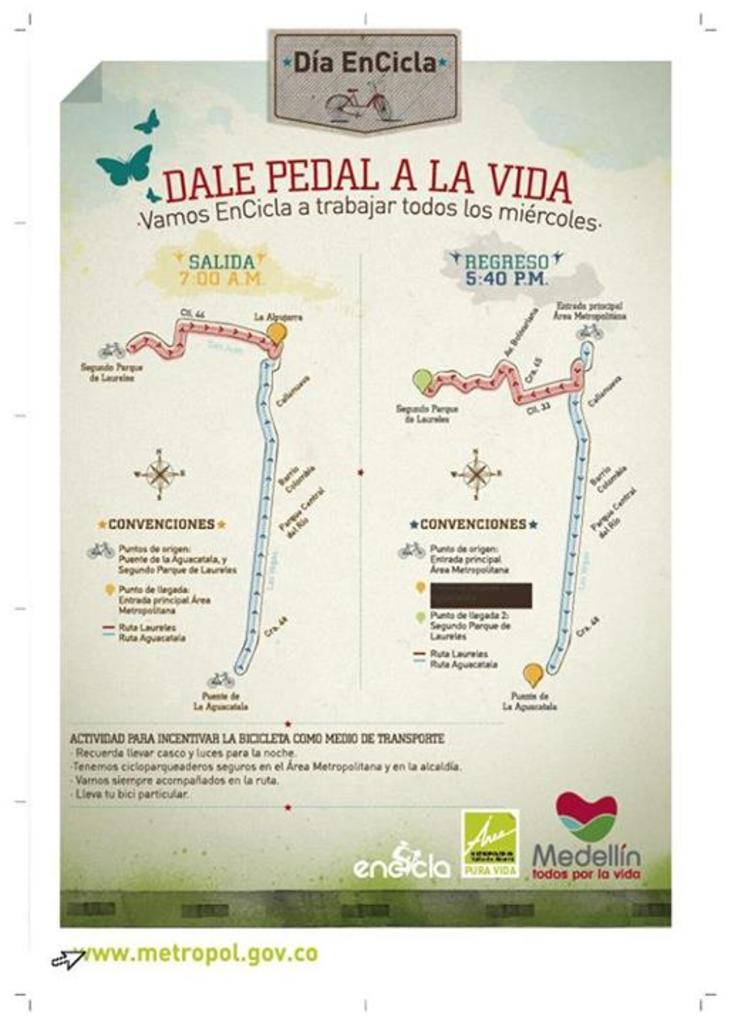<image>
Render a clear and concise summary of the photo. A poster of Dale Pedal A La Vida with some pictures on it. 